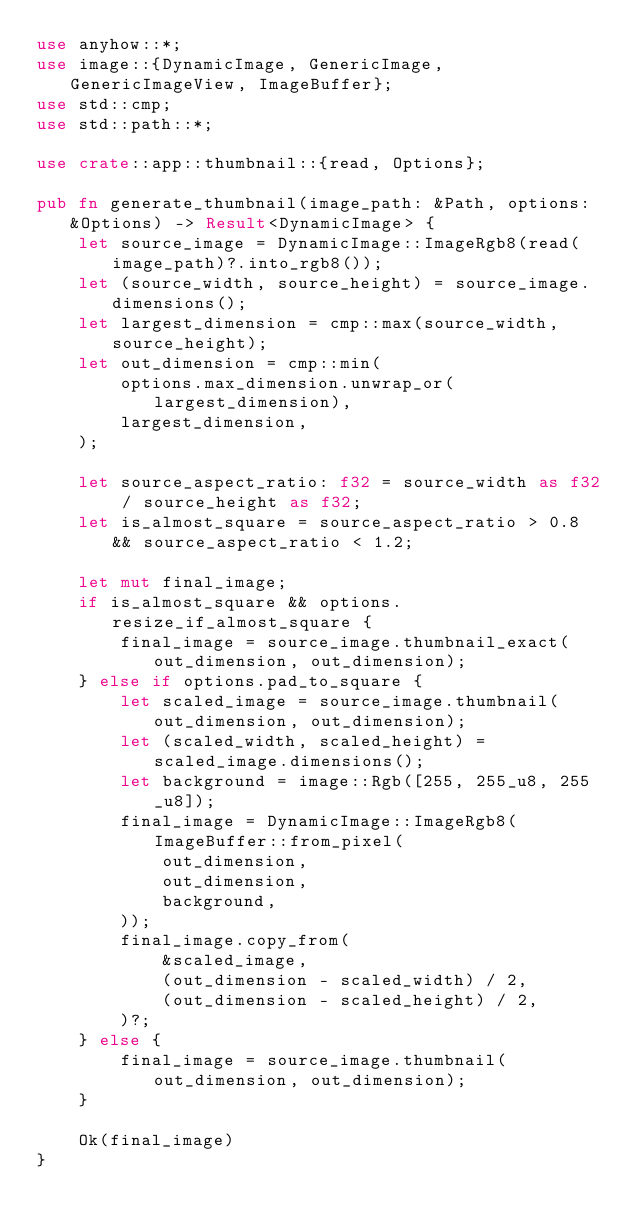<code> <loc_0><loc_0><loc_500><loc_500><_Rust_>use anyhow::*;
use image::{DynamicImage, GenericImage, GenericImageView, ImageBuffer};
use std::cmp;
use std::path::*;

use crate::app::thumbnail::{read, Options};

pub fn generate_thumbnail(image_path: &Path, options: &Options) -> Result<DynamicImage> {
	let source_image = DynamicImage::ImageRgb8(read(image_path)?.into_rgb8());
	let (source_width, source_height) = source_image.dimensions();
	let largest_dimension = cmp::max(source_width, source_height);
	let out_dimension = cmp::min(
		options.max_dimension.unwrap_or(largest_dimension),
		largest_dimension,
	);

	let source_aspect_ratio: f32 = source_width as f32 / source_height as f32;
	let is_almost_square = source_aspect_ratio > 0.8 && source_aspect_ratio < 1.2;

	let mut final_image;
	if is_almost_square && options.resize_if_almost_square {
		final_image = source_image.thumbnail_exact(out_dimension, out_dimension);
	} else if options.pad_to_square {
		let scaled_image = source_image.thumbnail(out_dimension, out_dimension);
		let (scaled_width, scaled_height) = scaled_image.dimensions();
		let background = image::Rgb([255, 255_u8, 255_u8]);
		final_image = DynamicImage::ImageRgb8(ImageBuffer::from_pixel(
			out_dimension,
			out_dimension,
			background,
		));
		final_image.copy_from(
			&scaled_image,
			(out_dimension - scaled_width) / 2,
			(out_dimension - scaled_height) / 2,
		)?;
	} else {
		final_image = source_image.thumbnail(out_dimension, out_dimension);
	}

	Ok(final_image)
}
</code> 